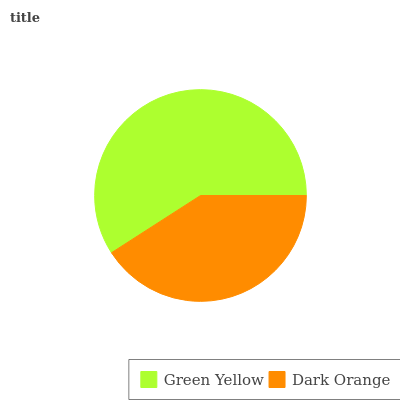Is Dark Orange the minimum?
Answer yes or no. Yes. Is Green Yellow the maximum?
Answer yes or no. Yes. Is Dark Orange the maximum?
Answer yes or no. No. Is Green Yellow greater than Dark Orange?
Answer yes or no. Yes. Is Dark Orange less than Green Yellow?
Answer yes or no. Yes. Is Dark Orange greater than Green Yellow?
Answer yes or no. No. Is Green Yellow less than Dark Orange?
Answer yes or no. No. Is Green Yellow the high median?
Answer yes or no. Yes. Is Dark Orange the low median?
Answer yes or no. Yes. Is Dark Orange the high median?
Answer yes or no. No. Is Green Yellow the low median?
Answer yes or no. No. 